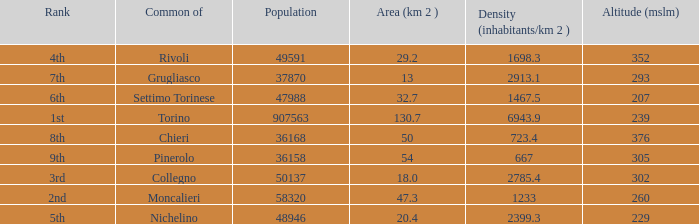The common of Chieri has what population density? 723.4. 